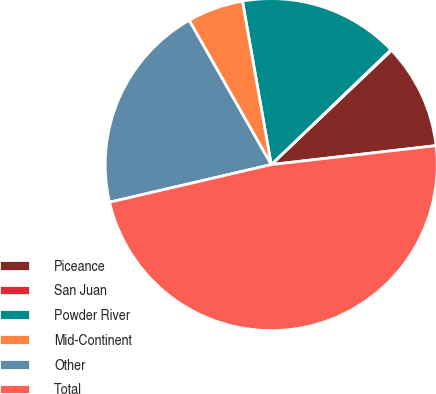<chart> <loc_0><loc_0><loc_500><loc_500><pie_chart><fcel>Piceance<fcel>San Juan<fcel>Powder River<fcel>Mid-Continent<fcel>Other<fcel>Total<nl><fcel>10.27%<fcel>0.08%<fcel>15.6%<fcel>5.46%<fcel>20.41%<fcel>48.18%<nl></chart> 